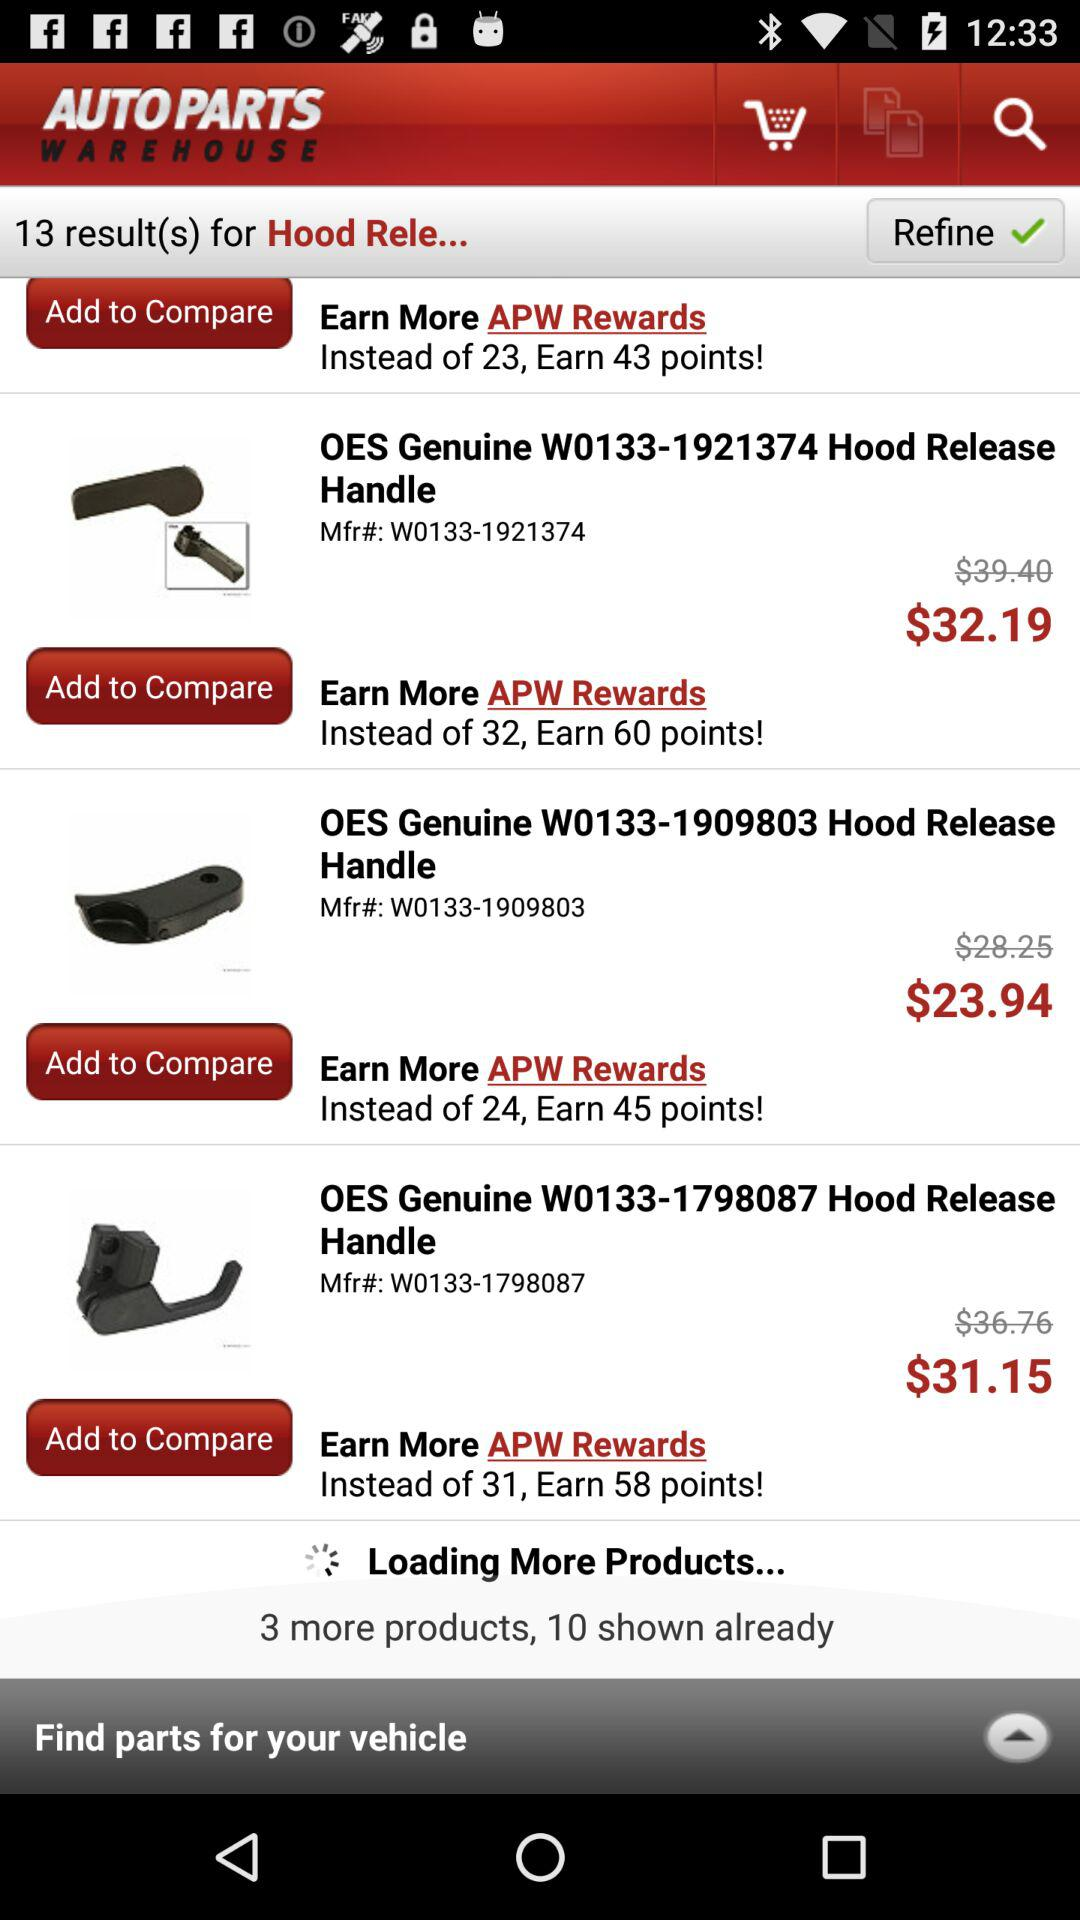How many parts are shown in total?
Answer the question using a single word or phrase. 13 